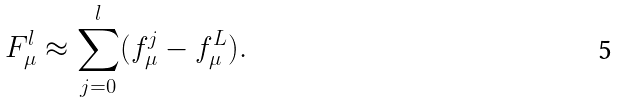Convert formula to latex. <formula><loc_0><loc_0><loc_500><loc_500>F _ { \mu } ^ { l } \approx \sum _ { j = 0 } ^ { l } ( f _ { \mu } ^ { j } - f _ { \mu } ^ { L } ) .</formula> 